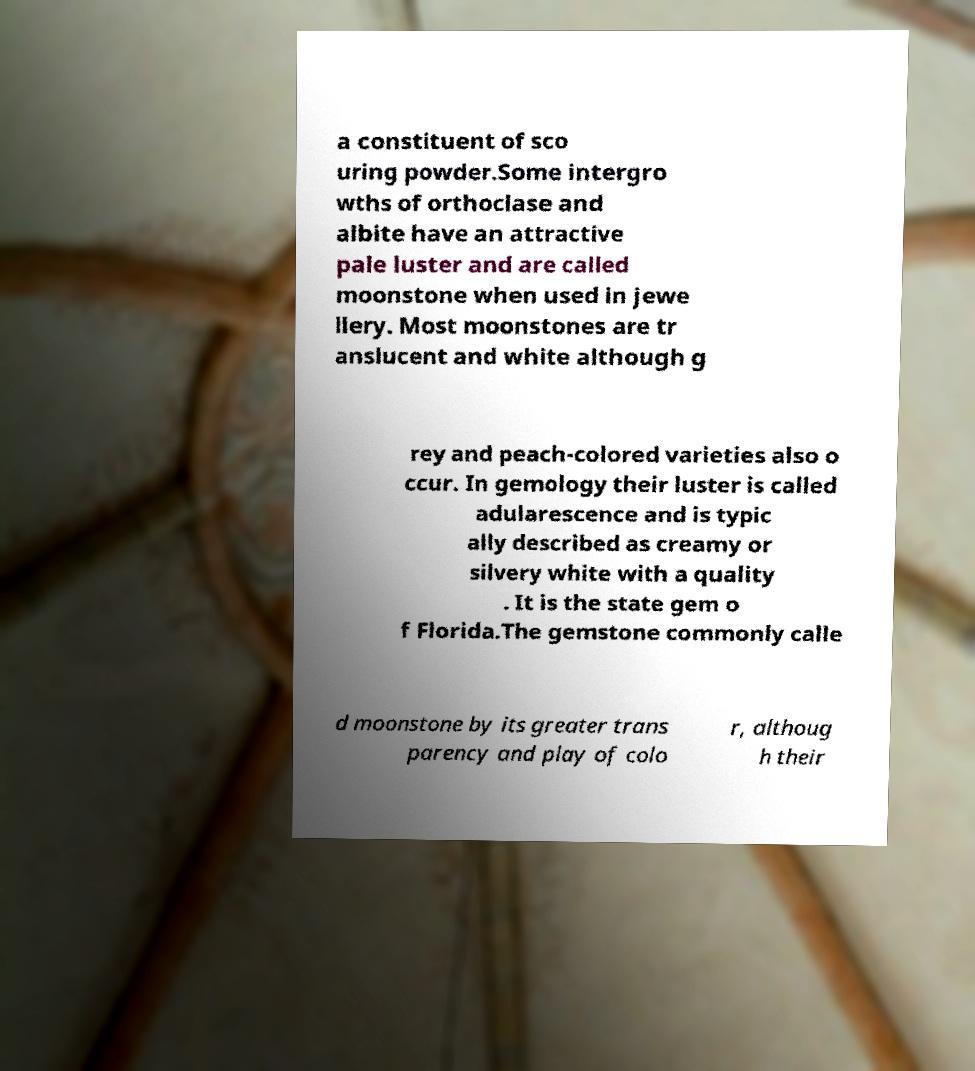What messages or text are displayed in this image? I need them in a readable, typed format. a constituent of sco uring powder.Some intergro wths of orthoclase and albite have an attractive pale luster and are called moonstone when used in jewe llery. Most moonstones are tr anslucent and white although g rey and peach-colored varieties also o ccur. In gemology their luster is called adularescence and is typic ally described as creamy or silvery white with a quality . It is the state gem o f Florida.The gemstone commonly calle d moonstone by its greater trans parency and play of colo r, althoug h their 